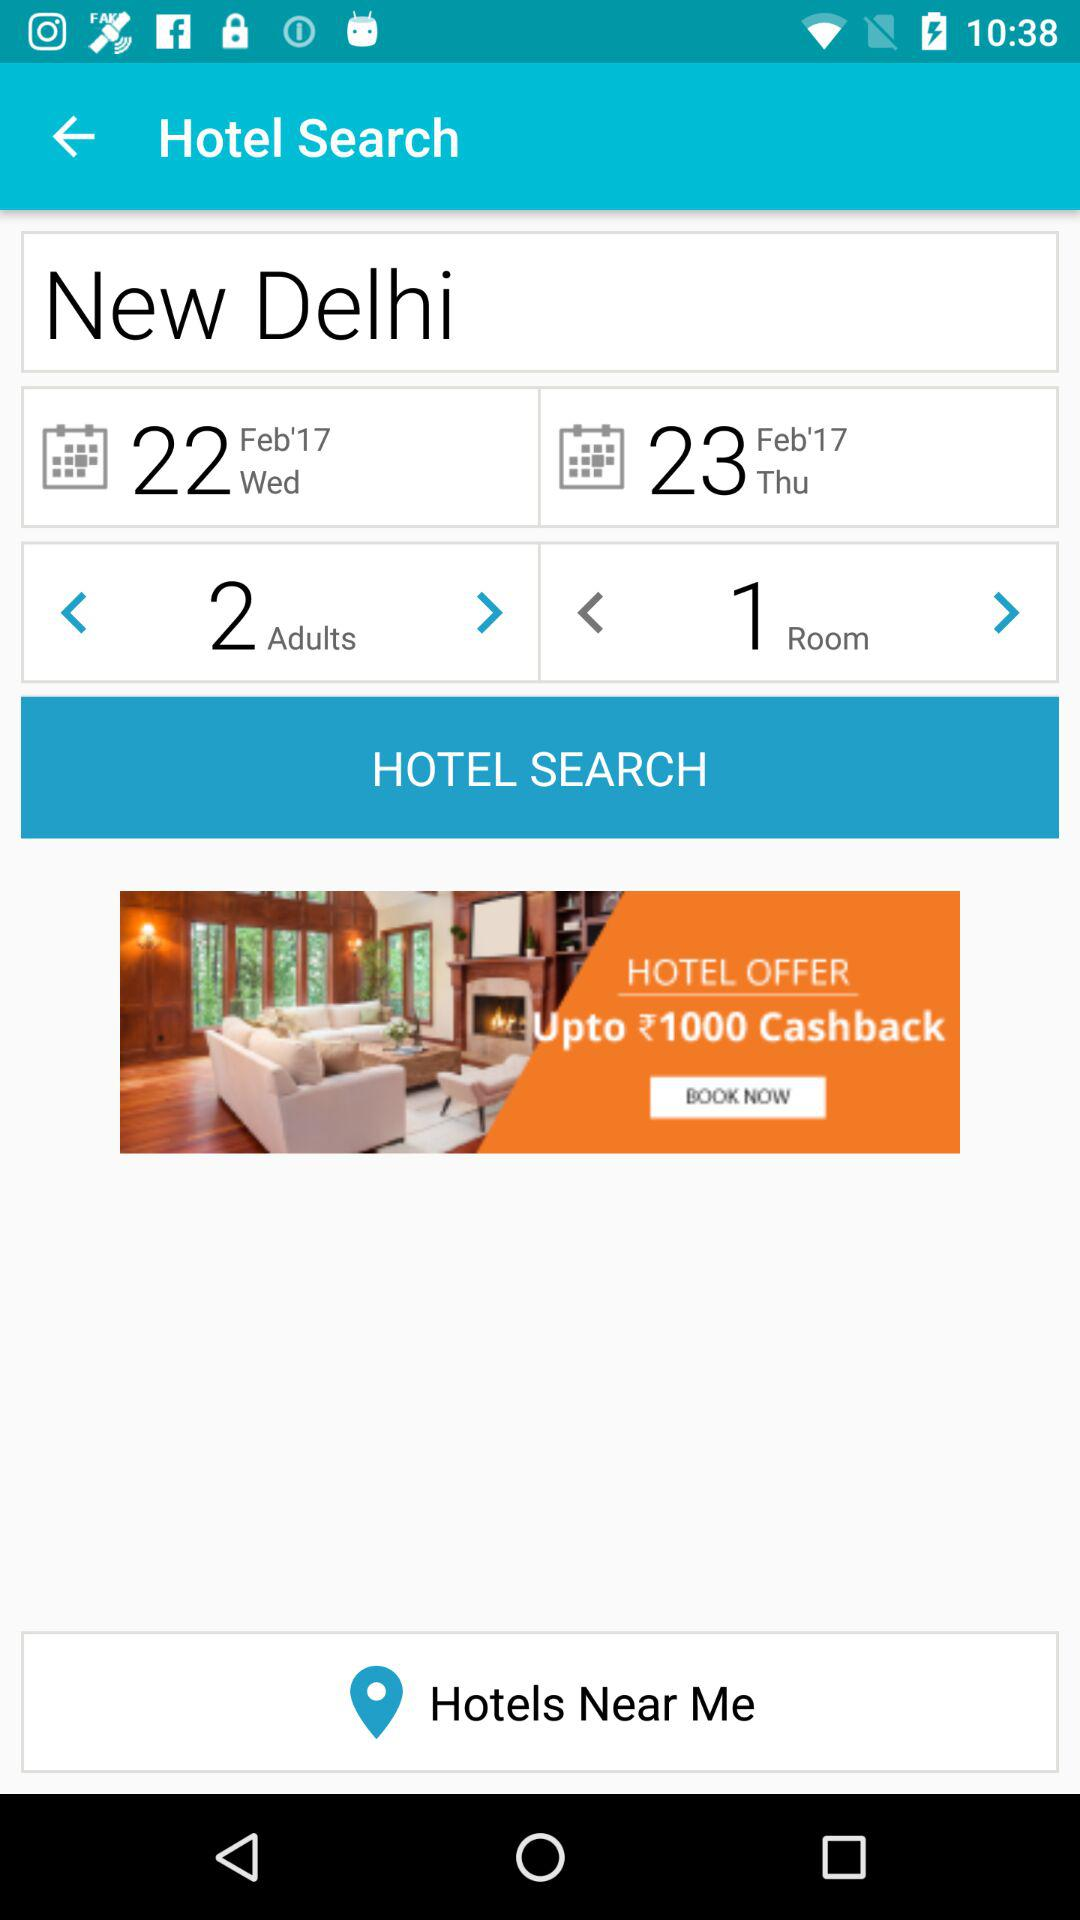How many rooms are there? There is 1 room. 